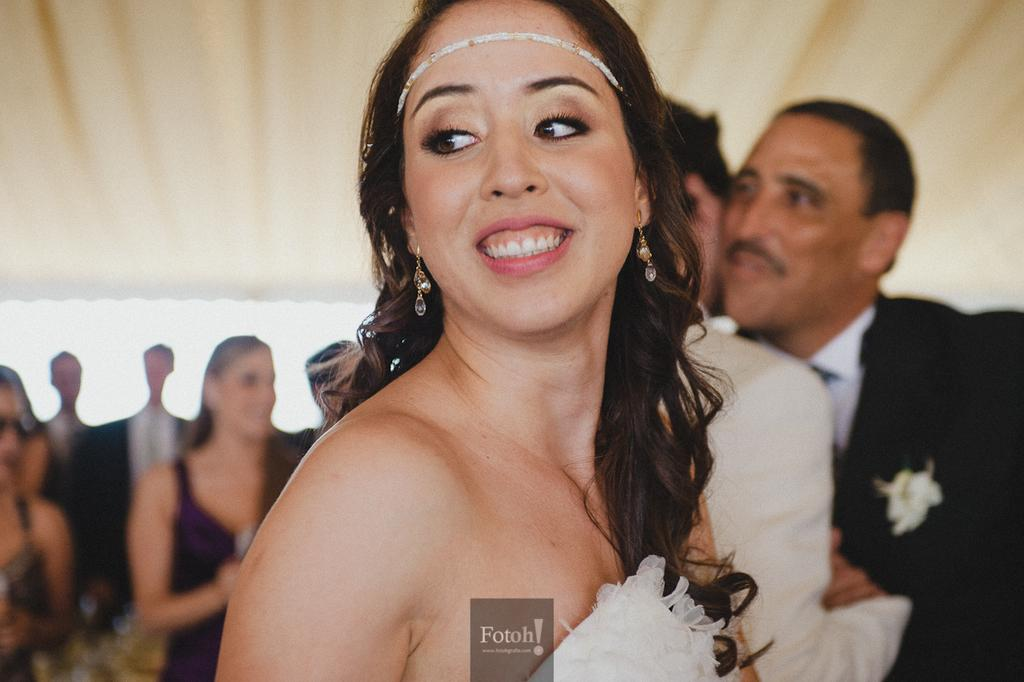Who is the main subject in the image? There is a lady in the center of the image. What is the lady doing in the image? The lady is standing and smiling. Can you describe the surrounding environment in the image? There are many people in the background of the image. What type of magic is the lady performing in the image? There is no indication of magic or any magical activity in the image. The lady is simply standing and smiling. 